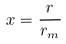Convert formula to latex. <formula><loc_0><loc_0><loc_500><loc_500>x = \frac { r } { r _ { m } }</formula> 